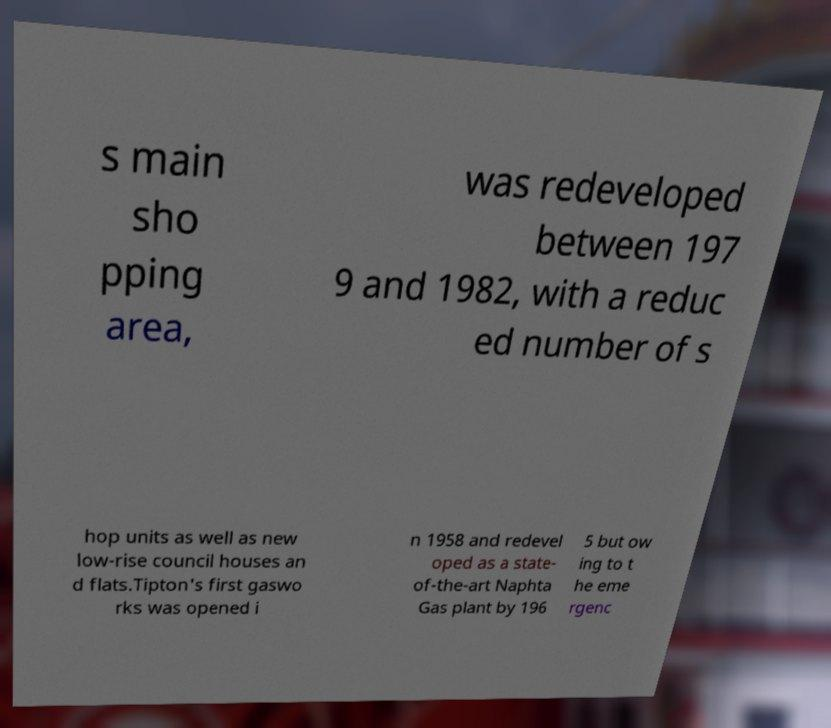Could you extract and type out the text from this image? s main sho pping area, was redeveloped between 197 9 and 1982, with a reduc ed number of s hop units as well as new low-rise council houses an d flats.Tipton's first gaswo rks was opened i n 1958 and redevel oped as a state- of-the-art Naphta Gas plant by 196 5 but ow ing to t he eme rgenc 